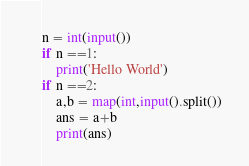Convert code to text. <code><loc_0><loc_0><loc_500><loc_500><_Python_>n = int(input())
if n ==1:
    print('Hello World')
if n ==2:
    a,b = map(int,input().split())
    ans = a+b
    print(ans)</code> 